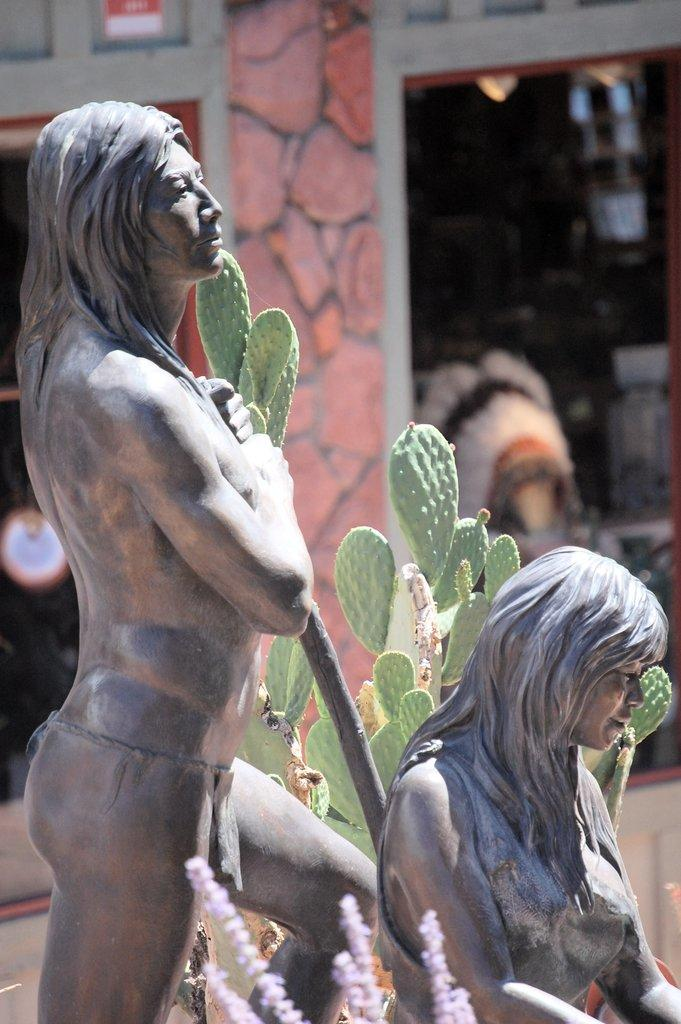What is the main subject of the image? There is a statue of two persons in the image. What can be seen in the background of the image? There is a plant in green color and glass walls in the background. How would you describe the color of the building in the background? The building in the background is gray in color. Can you tell me how many pets are visible in the image? There are no pets present in the image. What type of grass can be seen growing on the edge of the statue? There is no grass visible in the image, and the statue does not have an edge. 